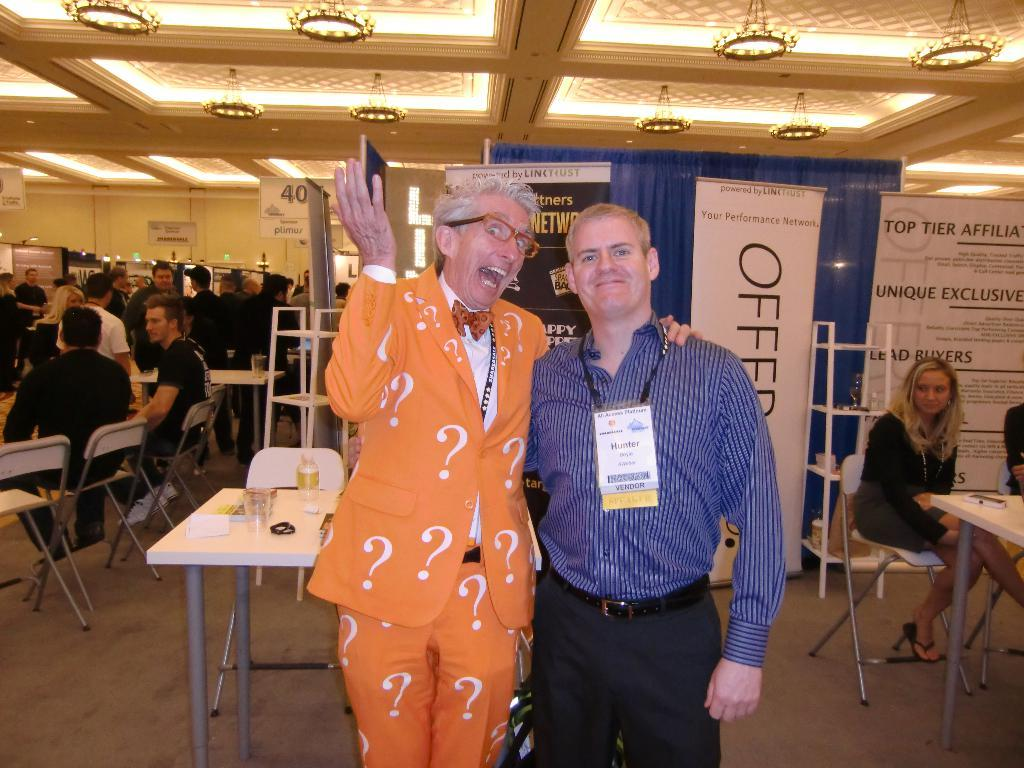How many people are visible in the image? There are two people standing in the image. What are the people in the background of the image doing? The people in the background of the image are sitting on chairs. What can be seen on the table in the image? There is a water bottle and a glass on the table. What type of pan is being used for educational purposes in the image? There is no pan or educational activity present in the image. 